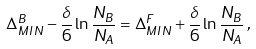<formula> <loc_0><loc_0><loc_500><loc_500>\Delta ^ { B } _ { M I N } - \frac { \delta } { 6 } \ln \frac { N _ { B } } { N _ { A } } = \Delta ^ { F } _ { M I N } + \frac { \delta } { 6 } \ln \frac { N _ { B } } { N _ { A } } \, ,</formula> 